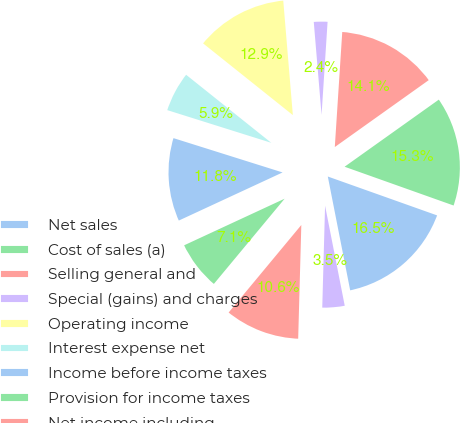Convert chart. <chart><loc_0><loc_0><loc_500><loc_500><pie_chart><fcel>Net sales<fcel>Cost of sales (a)<fcel>Selling general and<fcel>Special (gains) and charges<fcel>Operating income<fcel>Interest expense net<fcel>Income before income taxes<fcel>Provision for income taxes<fcel>Net income including<fcel>Net income attributable to<nl><fcel>16.47%<fcel>15.29%<fcel>14.12%<fcel>2.36%<fcel>12.94%<fcel>5.88%<fcel>11.76%<fcel>7.06%<fcel>10.59%<fcel>3.53%<nl></chart> 